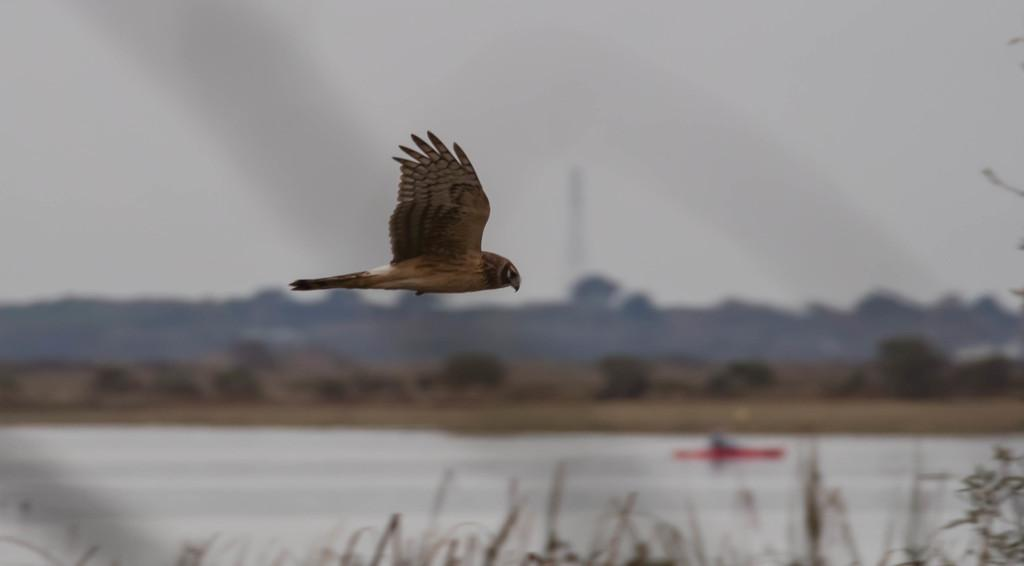What type of animal can be seen in the image? There is a bird in the image. What can be seen in the background of the image? There are trees and water visible in the background of the image. What type of vegetation is at the bottom of the image? There is grass at the bottom of the image. What is visible at the top of the image? The sky is visible at the top of the image. How many children are playing with the plough in the image? There are no children or plough present in the image. What is the mass of the bird in the image? The mass of the bird cannot be determined from the image alone. 